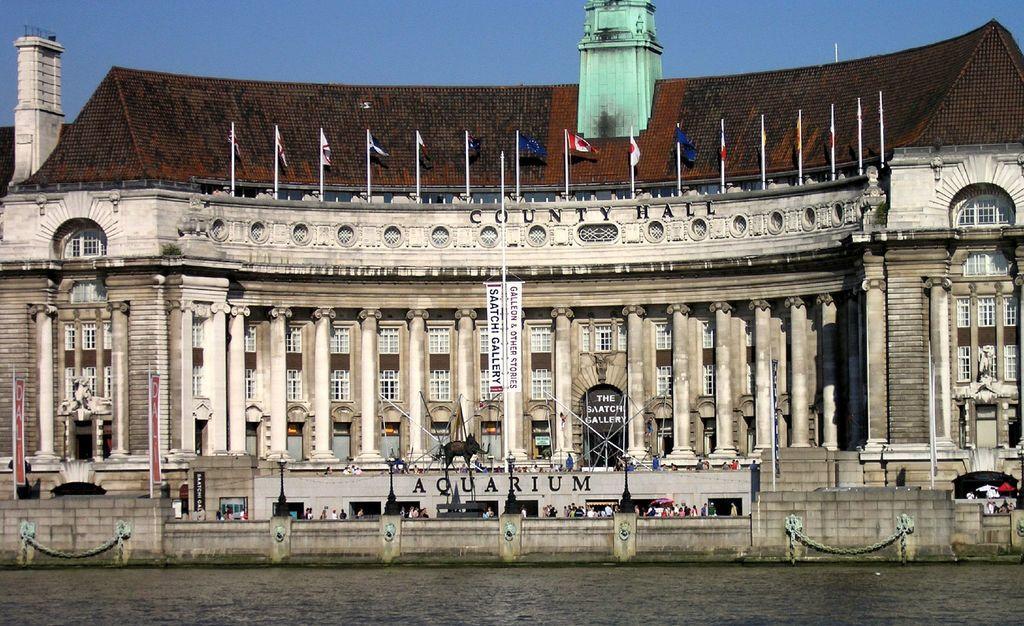Can you describe this image briefly? In this image I can see a building. There are few persons. I can see few flags. At the bottom it is looking like a water surface. At the top I can see the sky. 